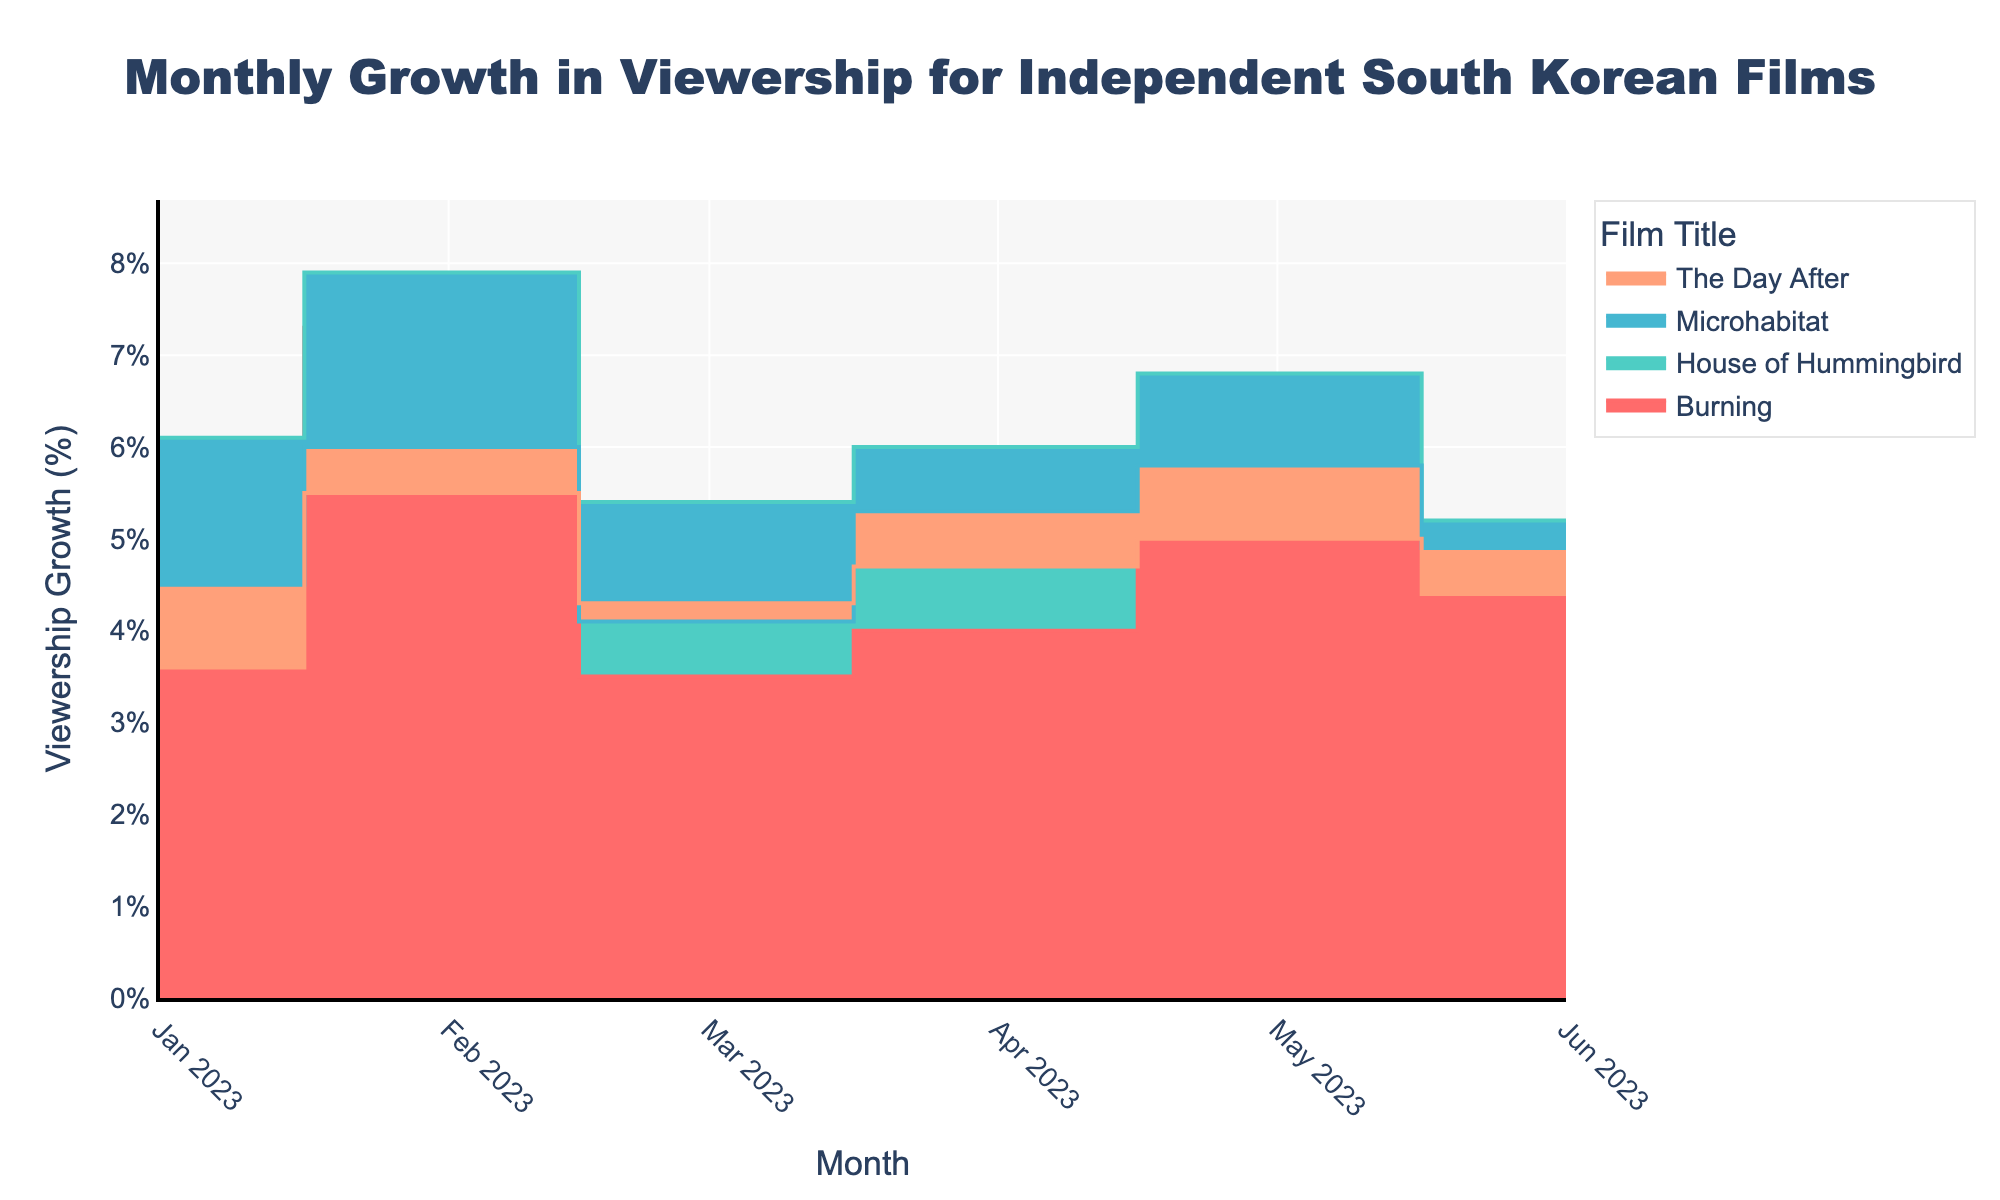What’s the title of the figure? The title is clearly displayed at the top of the figure. By looking at the top of the graph, the title can be read easily.
Answer: Monthly Growth in Viewership for Independent South Korean Films How many films are visualized in the chart? Each film has a separate line with a different color. By counting the number of distinct lines in the figure, you can determine the number of films.
Answer: 4 Which film shows the highest viewership growth in February 2023? Locate February 2023 on the x-axis and compare the y-values (viewership growth percentages) of all films in that month. The film with the highest y-value in February 2023 is the answer.
Answer: House of Hummingbird What is the average viewership growth for "Burning" from January to June 2023? Sum the viewership growth percentages for "Burning" from January to June (5.2 + 7.3 + 3.5 + 4.0 + 5.1 + 4.7) and divide by the number of months (6). Calculation: Total = 29.8, Average = 29.8/6.
Answer: 4.97% Which month shows the biggest difference in viewership growth between "Burning" and "House of Hummingbird"? For each month from January to June, subtract the viewership growth of "Burning" from "House of Hummingbird" and identify the month with the largest absolute difference.
Answer: February 2023 Which film had the most consistent (least variable) viewership growth from January to June 2023? Calculate the range (maximum - minimum) of the viewership growth percentages for each film from January to June. The film with the smallest range is the most consistent.
Answer: The Day After When did "Microhabitat" achieve its peak viewership growth within the given timeframe? Identify the highest point on the "Microhabitat" trace and check the corresponding month on the x-axis.
Answer: May 2023 How do the viewership growth trends of "Burning" and "The Day After" compare from March to April 2023? Examine the lines for both films between March and April, noticing if they rise, fall, or stay consistent. "Burning" increases from 3.5% to 4.0%, and "The Day After" also increases from 4.3% to 4.7%.
Answer: Both increased What was the total viewership growth percentage for "House of Hummingbird" in the first quarter (January to March) of 2023? Sum the viewership growth percentages for "House of Hummingbird" in January, February, and March (6.1 + 7.9 + 5.4). Calculation: Total = 19.4%.
Answer: 19.4% What unique characteristic of this chart type (Step Area Chart) helps in identifying changes in viewership over time? The Step Area Chart uses horizontal and vertical lines to connect data points, filling the space beneath each line with color. This makes it easy to see changes and trends over time as the stepped areas indicate shifts in viewership more distinctly than smooth lines.
Answer: Stepped areas showing shifts 